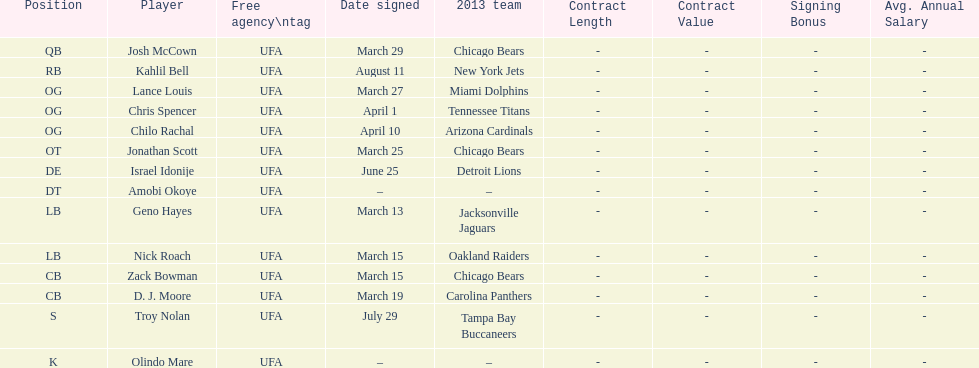The person's first name shares the same name as a nation. Israel Idonije. 